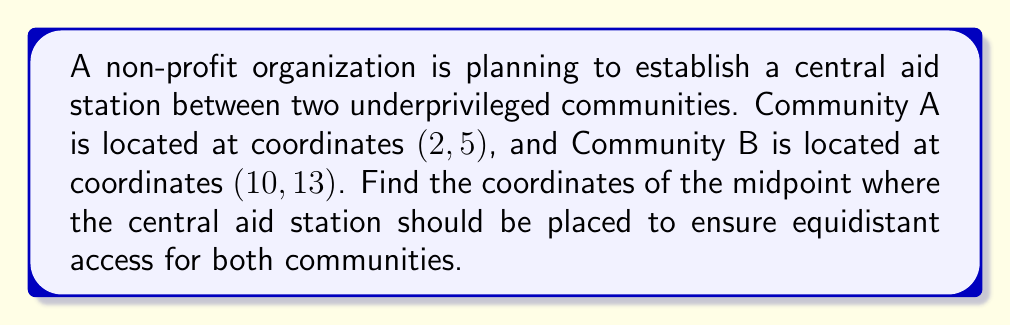Solve this math problem. To find the midpoint between two points, we use the midpoint formula:

$$\text{Midpoint} = \left(\frac{x_1 + x_2}{2}, \frac{y_1 + y_2}{2}\right)$$

Where $(x_1, y_1)$ are the coordinates of the first point and $(x_2, y_2)$ are the coordinates of the second point.

Let's substitute the given coordinates:
Community A: $(x_1, y_1) = (2, 5)$
Community B: $(x_2, y_2) = (10, 13)$

Now, let's calculate the x-coordinate of the midpoint:
$$x = \frac{x_1 + x_2}{2} = \frac{2 + 10}{2} = \frac{12}{2} = 6$$

Next, let's calculate the y-coordinate of the midpoint:
$$y = \frac{y_1 + y_2}{2} = \frac{5 + 13}{2} = \frac{18}{2} = 9$$

Therefore, the coordinates of the midpoint where the central aid station should be placed are (6, 9).

[asy]
unitsize(0.5cm);
dot((2,5));
dot((10,13));
dot((6,9));
label("A (2, 5)", (2,5), SW);
label("B (10, 13)", (10,13), NE);
label("Midpoint (6, 9)", (6,9), SE);
draw((2,5)--(10,13), dashed);
draw((0,0)--(12,14), Arrow);
draw((0,0)--(0,14), Arrow);
label("x", (12,0), S);
label("y", (0,14), W);
[/asy]
Answer: The coordinates of the central aid station should be (6, 9). 